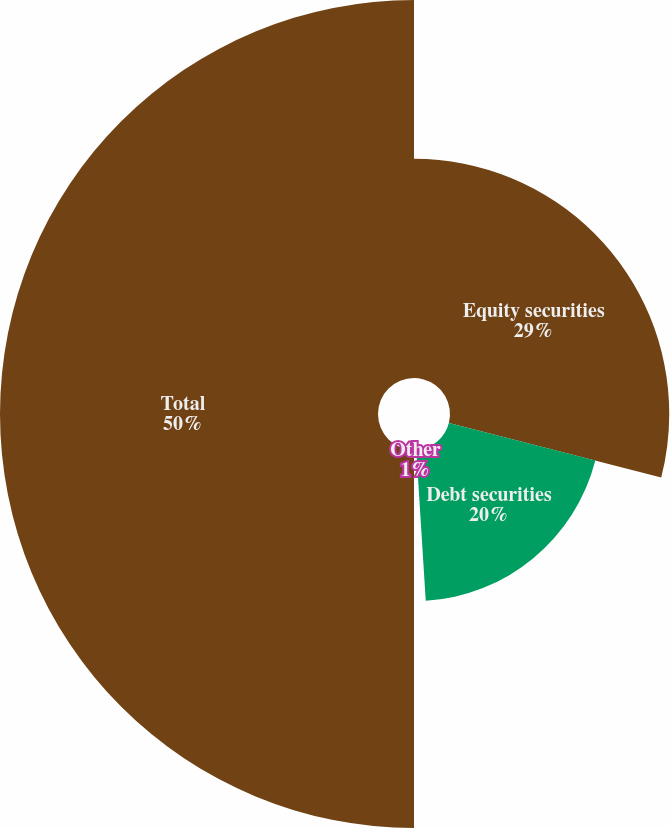Convert chart to OTSL. <chart><loc_0><loc_0><loc_500><loc_500><pie_chart><fcel>Equity securities<fcel>Debt securities<fcel>Other<fcel>Total<nl><fcel>29.0%<fcel>20.0%<fcel>1.0%<fcel>50.0%<nl></chart> 